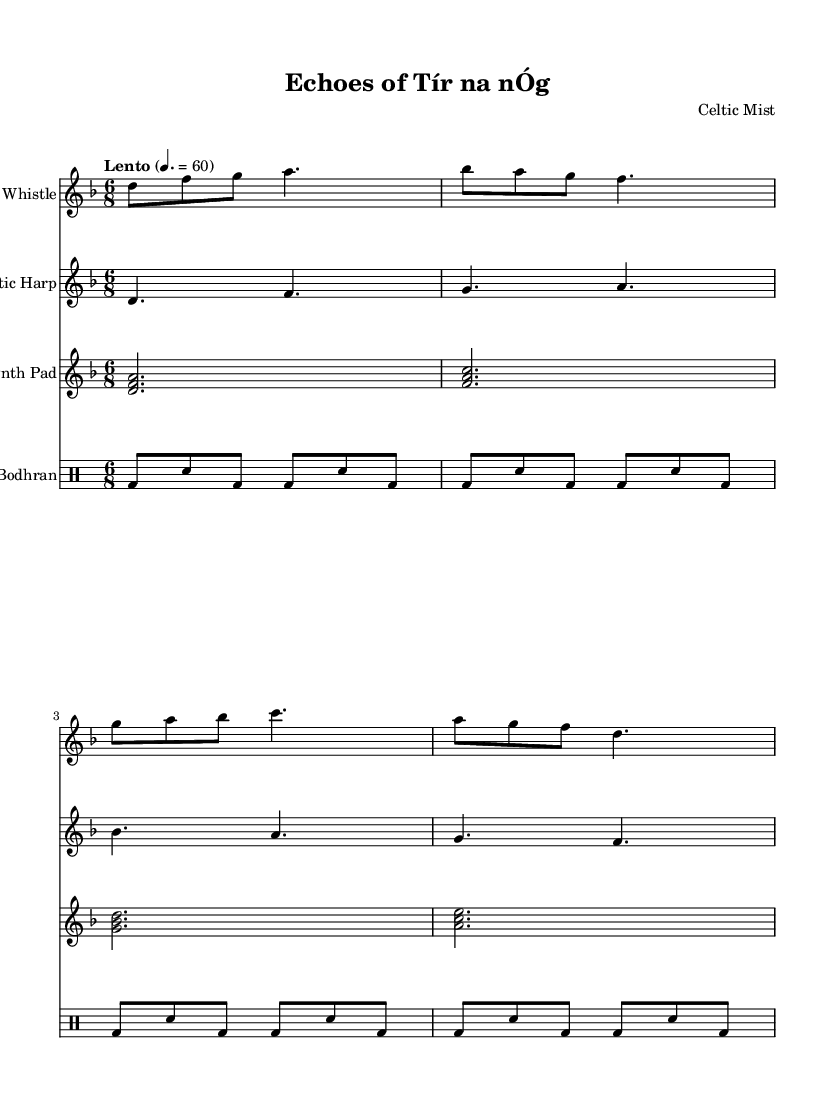What is the key signature of this music? The key signature is D minor, which has one flat (B flat). This can be identified at the beginning of the score where the key signature is indicated.
Answer: D minor What is the time signature of this music? The time signature is 6/8, which is shown at the beginning of the score. This indicates that there are six eighth notes per measure.
Answer: 6/8 What is the tempo marking for this piece? The tempo marking is "Lento," which indicates a slow pace. This is typically found in the tempo indication at the beginning of the score.
Answer: Lento How many staves are used for the tin whistle? The tin whistle has one staff that contains its part in the score. This can be determined by counting the number of separate systems in the score dedicated to different instruments.
Answer: One Which instrument plays the melody in this piece? The melody is played by the Tin Whistle, as it is the only staff that presents a distinct melodic line at the top of the score.
Answer: Tin Whistle What type of rhythm pattern does the bodhran follow? The bodhran follows a repeating pattern of alternating bass drum sounds and snare hits, as displayed in the rhythmic notation through the bars in its staff. This creates a consistent percussive backdrop.
Answer: Alternating bass and snare What chords are represented in the synthesizer pad line? The synthesizer pad includes different triads represented in a melodic form, with the chords indicated by the notes played simultaneously (for example, the first chord is D minor). This can be identified by the note groupings in each measure.
Answer: D minor, F major, G minor, A major 